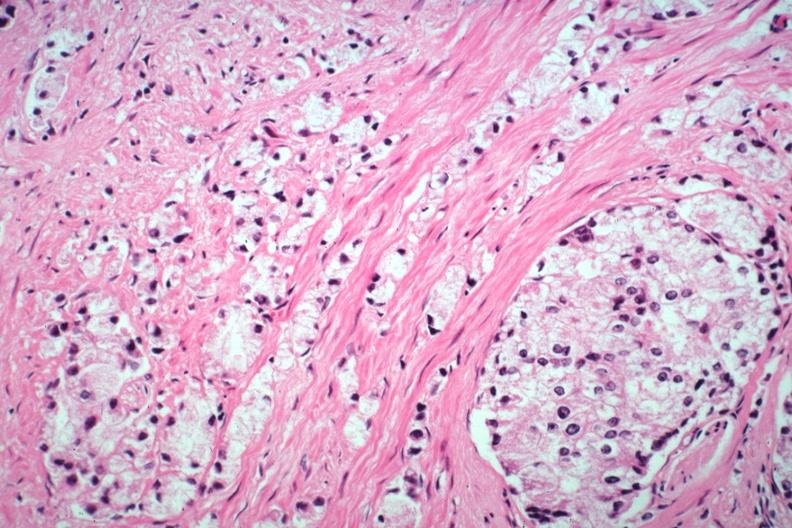s prostate present?
Answer the question using a single word or phrase. Yes 